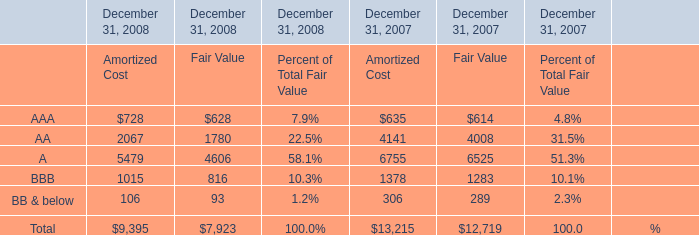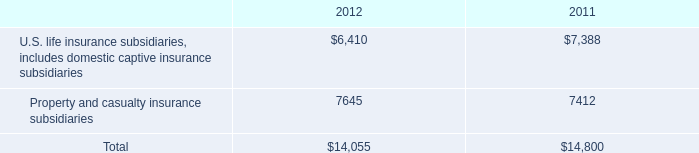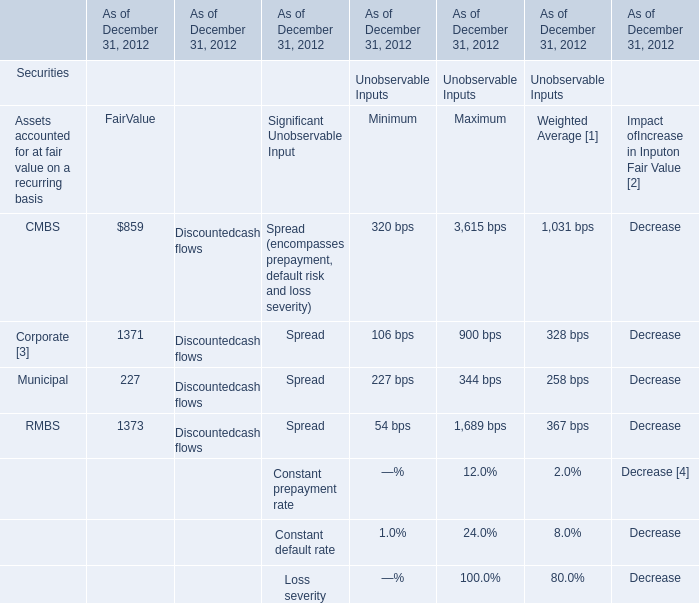What is the sum of FairValue in the range of 800 and 1400 in 2012? 
Computations: ((859 + 1371) + 1371)
Answer: 3601.0. 